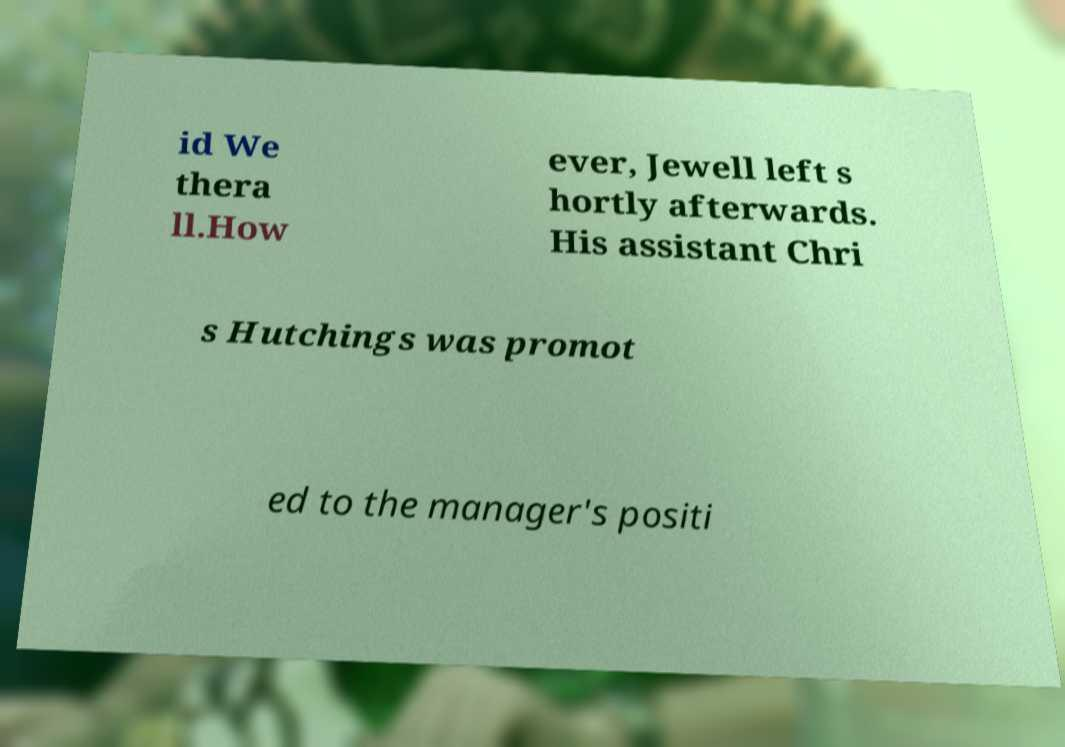For documentation purposes, I need the text within this image transcribed. Could you provide that? id We thera ll.How ever, Jewell left s hortly afterwards. His assistant Chri s Hutchings was promot ed to the manager's positi 